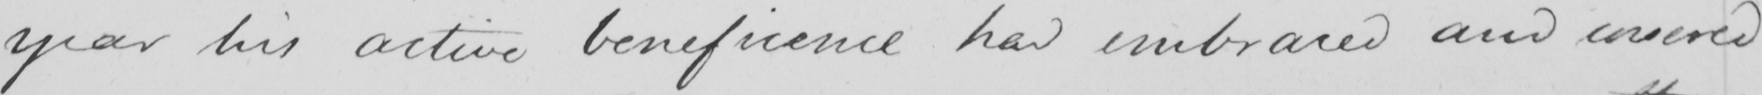What is written in this line of handwriting? year his active beneficence had embraced and covered 